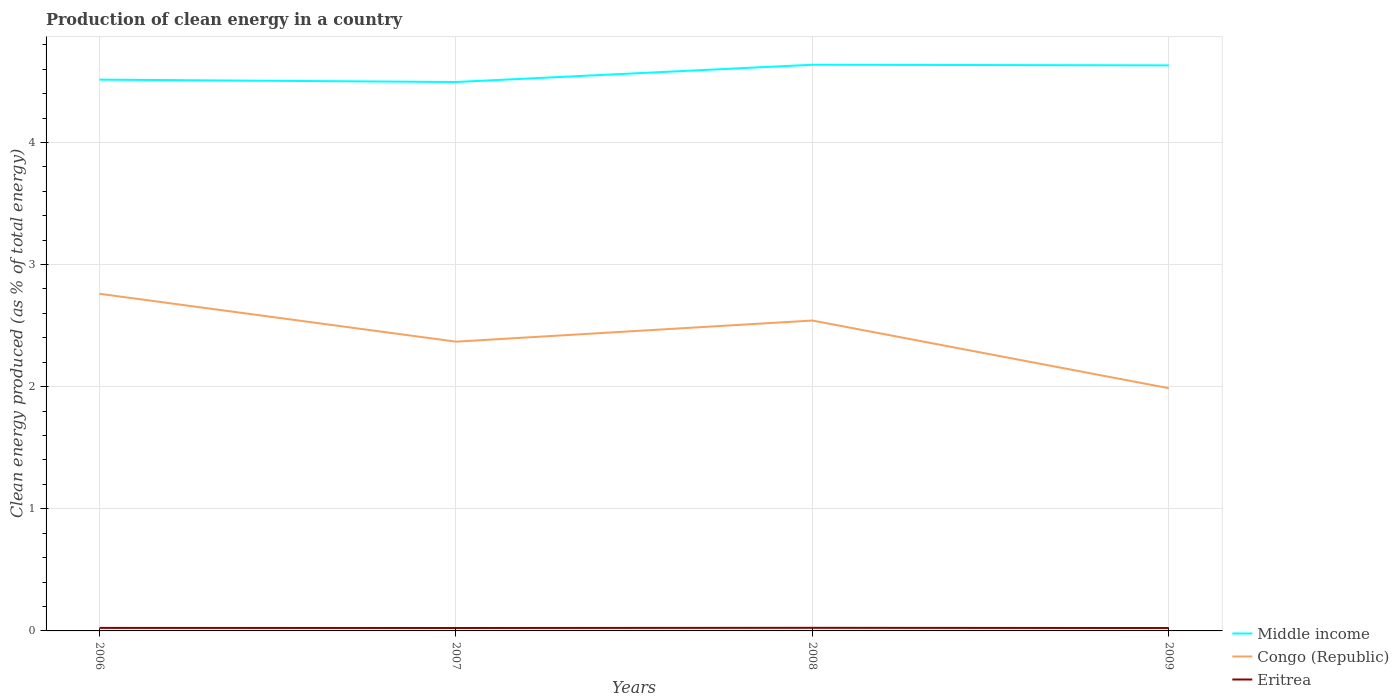How many different coloured lines are there?
Your answer should be compact. 3. Is the number of lines equal to the number of legend labels?
Keep it short and to the point. Yes. Across all years, what is the maximum percentage of clean energy produced in Eritrea?
Ensure brevity in your answer.  0.02. In which year was the percentage of clean energy produced in Middle income maximum?
Provide a short and direct response. 2007. What is the total percentage of clean energy produced in Middle income in the graph?
Make the answer very short. -0.14. What is the difference between the highest and the second highest percentage of clean energy produced in Congo (Republic)?
Ensure brevity in your answer.  0.77. What is the difference between the highest and the lowest percentage of clean energy produced in Congo (Republic)?
Ensure brevity in your answer.  2. Is the percentage of clean energy produced in Middle income strictly greater than the percentage of clean energy produced in Eritrea over the years?
Your response must be concise. No. How many lines are there?
Your answer should be very brief. 3. How many years are there in the graph?
Keep it short and to the point. 4. Does the graph contain grids?
Offer a terse response. Yes. How many legend labels are there?
Make the answer very short. 3. How are the legend labels stacked?
Offer a very short reply. Vertical. What is the title of the graph?
Ensure brevity in your answer.  Production of clean energy in a country. Does "Pakistan" appear as one of the legend labels in the graph?
Give a very brief answer. No. What is the label or title of the X-axis?
Your answer should be very brief. Years. What is the label or title of the Y-axis?
Provide a short and direct response. Clean energy produced (as % of total energy). What is the Clean energy produced (as % of total energy) in Middle income in 2006?
Your response must be concise. 4.51. What is the Clean energy produced (as % of total energy) of Congo (Republic) in 2006?
Ensure brevity in your answer.  2.76. What is the Clean energy produced (as % of total energy) of Eritrea in 2006?
Ensure brevity in your answer.  0.02. What is the Clean energy produced (as % of total energy) of Middle income in 2007?
Ensure brevity in your answer.  4.49. What is the Clean energy produced (as % of total energy) of Congo (Republic) in 2007?
Ensure brevity in your answer.  2.37. What is the Clean energy produced (as % of total energy) of Eritrea in 2007?
Ensure brevity in your answer.  0.02. What is the Clean energy produced (as % of total energy) of Middle income in 2008?
Make the answer very short. 4.64. What is the Clean energy produced (as % of total energy) of Congo (Republic) in 2008?
Ensure brevity in your answer.  2.54. What is the Clean energy produced (as % of total energy) in Eritrea in 2008?
Keep it short and to the point. 0.03. What is the Clean energy produced (as % of total energy) in Middle income in 2009?
Keep it short and to the point. 4.63. What is the Clean energy produced (as % of total energy) of Congo (Republic) in 2009?
Offer a very short reply. 1.99. What is the Clean energy produced (as % of total energy) of Eritrea in 2009?
Ensure brevity in your answer.  0.02. Across all years, what is the maximum Clean energy produced (as % of total energy) of Middle income?
Offer a terse response. 4.64. Across all years, what is the maximum Clean energy produced (as % of total energy) in Congo (Republic)?
Offer a terse response. 2.76. Across all years, what is the maximum Clean energy produced (as % of total energy) in Eritrea?
Provide a short and direct response. 0.03. Across all years, what is the minimum Clean energy produced (as % of total energy) in Middle income?
Offer a very short reply. 4.49. Across all years, what is the minimum Clean energy produced (as % of total energy) of Congo (Republic)?
Give a very brief answer. 1.99. Across all years, what is the minimum Clean energy produced (as % of total energy) of Eritrea?
Give a very brief answer. 0.02. What is the total Clean energy produced (as % of total energy) of Middle income in the graph?
Offer a terse response. 18.28. What is the total Clean energy produced (as % of total energy) of Congo (Republic) in the graph?
Your response must be concise. 9.66. What is the total Clean energy produced (as % of total energy) of Eritrea in the graph?
Keep it short and to the point. 0.1. What is the difference between the Clean energy produced (as % of total energy) in Middle income in 2006 and that in 2007?
Your answer should be very brief. 0.02. What is the difference between the Clean energy produced (as % of total energy) in Congo (Republic) in 2006 and that in 2007?
Offer a terse response. 0.39. What is the difference between the Clean energy produced (as % of total energy) of Eritrea in 2006 and that in 2007?
Ensure brevity in your answer.  0. What is the difference between the Clean energy produced (as % of total energy) of Middle income in 2006 and that in 2008?
Make the answer very short. -0.12. What is the difference between the Clean energy produced (as % of total energy) in Congo (Republic) in 2006 and that in 2008?
Your answer should be compact. 0.22. What is the difference between the Clean energy produced (as % of total energy) in Eritrea in 2006 and that in 2008?
Keep it short and to the point. -0. What is the difference between the Clean energy produced (as % of total energy) of Middle income in 2006 and that in 2009?
Provide a short and direct response. -0.12. What is the difference between the Clean energy produced (as % of total energy) of Congo (Republic) in 2006 and that in 2009?
Provide a short and direct response. 0.77. What is the difference between the Clean energy produced (as % of total energy) in Eritrea in 2006 and that in 2009?
Give a very brief answer. 0. What is the difference between the Clean energy produced (as % of total energy) in Middle income in 2007 and that in 2008?
Your response must be concise. -0.14. What is the difference between the Clean energy produced (as % of total energy) of Congo (Republic) in 2007 and that in 2008?
Provide a succinct answer. -0.17. What is the difference between the Clean energy produced (as % of total energy) in Eritrea in 2007 and that in 2008?
Your answer should be compact. -0. What is the difference between the Clean energy produced (as % of total energy) in Middle income in 2007 and that in 2009?
Offer a terse response. -0.14. What is the difference between the Clean energy produced (as % of total energy) in Congo (Republic) in 2007 and that in 2009?
Offer a terse response. 0.38. What is the difference between the Clean energy produced (as % of total energy) in Middle income in 2008 and that in 2009?
Make the answer very short. 0.01. What is the difference between the Clean energy produced (as % of total energy) of Congo (Republic) in 2008 and that in 2009?
Give a very brief answer. 0.55. What is the difference between the Clean energy produced (as % of total energy) of Eritrea in 2008 and that in 2009?
Your answer should be compact. 0. What is the difference between the Clean energy produced (as % of total energy) of Middle income in 2006 and the Clean energy produced (as % of total energy) of Congo (Republic) in 2007?
Offer a terse response. 2.15. What is the difference between the Clean energy produced (as % of total energy) of Middle income in 2006 and the Clean energy produced (as % of total energy) of Eritrea in 2007?
Make the answer very short. 4.49. What is the difference between the Clean energy produced (as % of total energy) of Congo (Republic) in 2006 and the Clean energy produced (as % of total energy) of Eritrea in 2007?
Offer a terse response. 2.74. What is the difference between the Clean energy produced (as % of total energy) of Middle income in 2006 and the Clean energy produced (as % of total energy) of Congo (Republic) in 2008?
Keep it short and to the point. 1.97. What is the difference between the Clean energy produced (as % of total energy) in Middle income in 2006 and the Clean energy produced (as % of total energy) in Eritrea in 2008?
Give a very brief answer. 4.49. What is the difference between the Clean energy produced (as % of total energy) of Congo (Republic) in 2006 and the Clean energy produced (as % of total energy) of Eritrea in 2008?
Your response must be concise. 2.74. What is the difference between the Clean energy produced (as % of total energy) in Middle income in 2006 and the Clean energy produced (as % of total energy) in Congo (Republic) in 2009?
Your response must be concise. 2.53. What is the difference between the Clean energy produced (as % of total energy) of Middle income in 2006 and the Clean energy produced (as % of total energy) of Eritrea in 2009?
Keep it short and to the point. 4.49. What is the difference between the Clean energy produced (as % of total energy) of Congo (Republic) in 2006 and the Clean energy produced (as % of total energy) of Eritrea in 2009?
Your answer should be compact. 2.74. What is the difference between the Clean energy produced (as % of total energy) in Middle income in 2007 and the Clean energy produced (as % of total energy) in Congo (Republic) in 2008?
Offer a very short reply. 1.95. What is the difference between the Clean energy produced (as % of total energy) of Middle income in 2007 and the Clean energy produced (as % of total energy) of Eritrea in 2008?
Offer a very short reply. 4.47. What is the difference between the Clean energy produced (as % of total energy) of Congo (Republic) in 2007 and the Clean energy produced (as % of total energy) of Eritrea in 2008?
Provide a succinct answer. 2.34. What is the difference between the Clean energy produced (as % of total energy) of Middle income in 2007 and the Clean energy produced (as % of total energy) of Congo (Republic) in 2009?
Offer a terse response. 2.51. What is the difference between the Clean energy produced (as % of total energy) of Middle income in 2007 and the Clean energy produced (as % of total energy) of Eritrea in 2009?
Ensure brevity in your answer.  4.47. What is the difference between the Clean energy produced (as % of total energy) of Congo (Republic) in 2007 and the Clean energy produced (as % of total energy) of Eritrea in 2009?
Provide a succinct answer. 2.35. What is the difference between the Clean energy produced (as % of total energy) of Middle income in 2008 and the Clean energy produced (as % of total energy) of Congo (Republic) in 2009?
Ensure brevity in your answer.  2.65. What is the difference between the Clean energy produced (as % of total energy) in Middle income in 2008 and the Clean energy produced (as % of total energy) in Eritrea in 2009?
Provide a short and direct response. 4.61. What is the difference between the Clean energy produced (as % of total energy) in Congo (Republic) in 2008 and the Clean energy produced (as % of total energy) in Eritrea in 2009?
Provide a succinct answer. 2.52. What is the average Clean energy produced (as % of total energy) in Middle income per year?
Provide a short and direct response. 4.57. What is the average Clean energy produced (as % of total energy) in Congo (Republic) per year?
Offer a very short reply. 2.41. What is the average Clean energy produced (as % of total energy) of Eritrea per year?
Make the answer very short. 0.02. In the year 2006, what is the difference between the Clean energy produced (as % of total energy) in Middle income and Clean energy produced (as % of total energy) in Congo (Republic)?
Give a very brief answer. 1.75. In the year 2006, what is the difference between the Clean energy produced (as % of total energy) in Middle income and Clean energy produced (as % of total energy) in Eritrea?
Keep it short and to the point. 4.49. In the year 2006, what is the difference between the Clean energy produced (as % of total energy) in Congo (Republic) and Clean energy produced (as % of total energy) in Eritrea?
Provide a short and direct response. 2.74. In the year 2007, what is the difference between the Clean energy produced (as % of total energy) in Middle income and Clean energy produced (as % of total energy) in Congo (Republic)?
Offer a very short reply. 2.13. In the year 2007, what is the difference between the Clean energy produced (as % of total energy) of Middle income and Clean energy produced (as % of total energy) of Eritrea?
Give a very brief answer. 4.47. In the year 2007, what is the difference between the Clean energy produced (as % of total energy) of Congo (Republic) and Clean energy produced (as % of total energy) of Eritrea?
Your response must be concise. 2.34. In the year 2008, what is the difference between the Clean energy produced (as % of total energy) of Middle income and Clean energy produced (as % of total energy) of Congo (Republic)?
Your answer should be very brief. 2.09. In the year 2008, what is the difference between the Clean energy produced (as % of total energy) in Middle income and Clean energy produced (as % of total energy) in Eritrea?
Provide a short and direct response. 4.61. In the year 2008, what is the difference between the Clean energy produced (as % of total energy) of Congo (Republic) and Clean energy produced (as % of total energy) of Eritrea?
Make the answer very short. 2.52. In the year 2009, what is the difference between the Clean energy produced (as % of total energy) in Middle income and Clean energy produced (as % of total energy) in Congo (Republic)?
Provide a succinct answer. 2.64. In the year 2009, what is the difference between the Clean energy produced (as % of total energy) in Middle income and Clean energy produced (as % of total energy) in Eritrea?
Provide a short and direct response. 4.61. In the year 2009, what is the difference between the Clean energy produced (as % of total energy) of Congo (Republic) and Clean energy produced (as % of total energy) of Eritrea?
Give a very brief answer. 1.96. What is the ratio of the Clean energy produced (as % of total energy) of Middle income in 2006 to that in 2007?
Provide a short and direct response. 1. What is the ratio of the Clean energy produced (as % of total energy) of Congo (Republic) in 2006 to that in 2007?
Keep it short and to the point. 1.17. What is the ratio of the Clean energy produced (as % of total energy) of Eritrea in 2006 to that in 2007?
Provide a succinct answer. 1.03. What is the ratio of the Clean energy produced (as % of total energy) of Middle income in 2006 to that in 2008?
Provide a succinct answer. 0.97. What is the ratio of the Clean energy produced (as % of total energy) in Congo (Republic) in 2006 to that in 2008?
Provide a succinct answer. 1.09. What is the ratio of the Clean energy produced (as % of total energy) in Eritrea in 2006 to that in 2008?
Provide a short and direct response. 0.97. What is the ratio of the Clean energy produced (as % of total energy) in Middle income in 2006 to that in 2009?
Keep it short and to the point. 0.97. What is the ratio of the Clean energy produced (as % of total energy) in Congo (Republic) in 2006 to that in 2009?
Your answer should be compact. 1.39. What is the ratio of the Clean energy produced (as % of total energy) of Eritrea in 2006 to that in 2009?
Provide a succinct answer. 1.04. What is the ratio of the Clean energy produced (as % of total energy) of Middle income in 2007 to that in 2008?
Give a very brief answer. 0.97. What is the ratio of the Clean energy produced (as % of total energy) of Congo (Republic) in 2007 to that in 2008?
Offer a very short reply. 0.93. What is the ratio of the Clean energy produced (as % of total energy) in Eritrea in 2007 to that in 2008?
Make the answer very short. 0.94. What is the ratio of the Clean energy produced (as % of total energy) of Middle income in 2007 to that in 2009?
Make the answer very short. 0.97. What is the ratio of the Clean energy produced (as % of total energy) in Congo (Republic) in 2007 to that in 2009?
Keep it short and to the point. 1.19. What is the ratio of the Clean energy produced (as % of total energy) of Eritrea in 2007 to that in 2009?
Give a very brief answer. 1.01. What is the ratio of the Clean energy produced (as % of total energy) in Congo (Republic) in 2008 to that in 2009?
Your answer should be compact. 1.28. What is the ratio of the Clean energy produced (as % of total energy) in Eritrea in 2008 to that in 2009?
Your response must be concise. 1.07. What is the difference between the highest and the second highest Clean energy produced (as % of total energy) in Middle income?
Your answer should be very brief. 0.01. What is the difference between the highest and the second highest Clean energy produced (as % of total energy) of Congo (Republic)?
Ensure brevity in your answer.  0.22. What is the difference between the highest and the second highest Clean energy produced (as % of total energy) of Eritrea?
Your response must be concise. 0. What is the difference between the highest and the lowest Clean energy produced (as % of total energy) in Middle income?
Ensure brevity in your answer.  0.14. What is the difference between the highest and the lowest Clean energy produced (as % of total energy) in Congo (Republic)?
Your answer should be compact. 0.77. What is the difference between the highest and the lowest Clean energy produced (as % of total energy) of Eritrea?
Your answer should be compact. 0. 